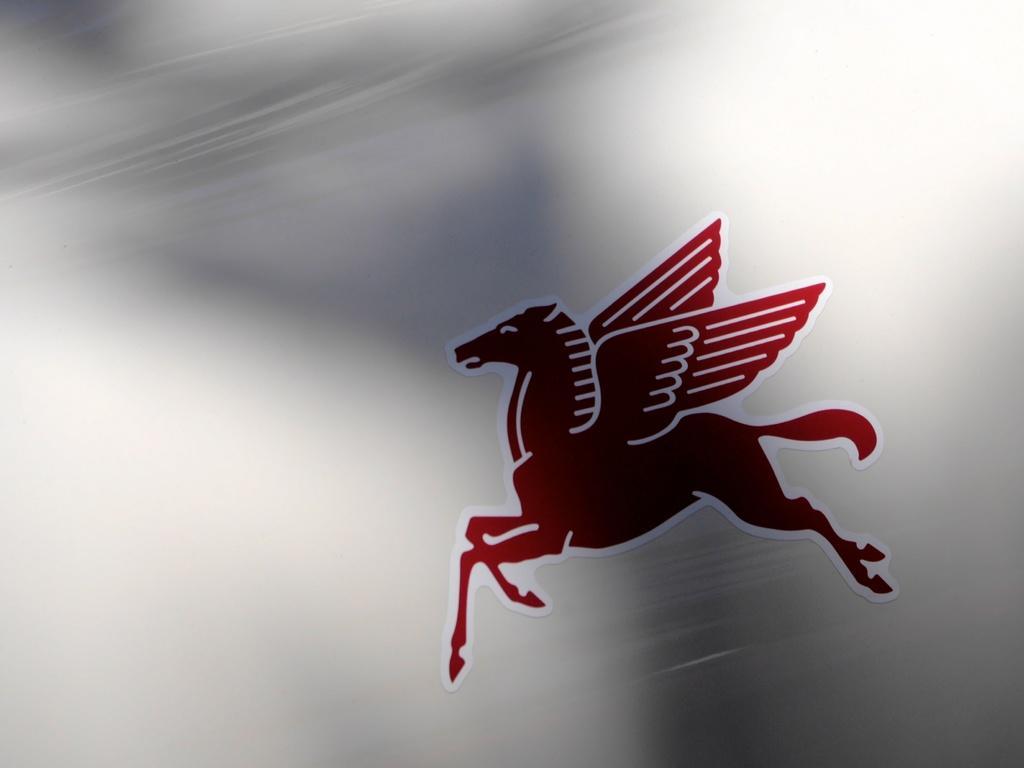How would you summarize this image in a sentence or two? In this image I can see the red and white color sticker to the white color surface. And this is a sticker of an animal. 